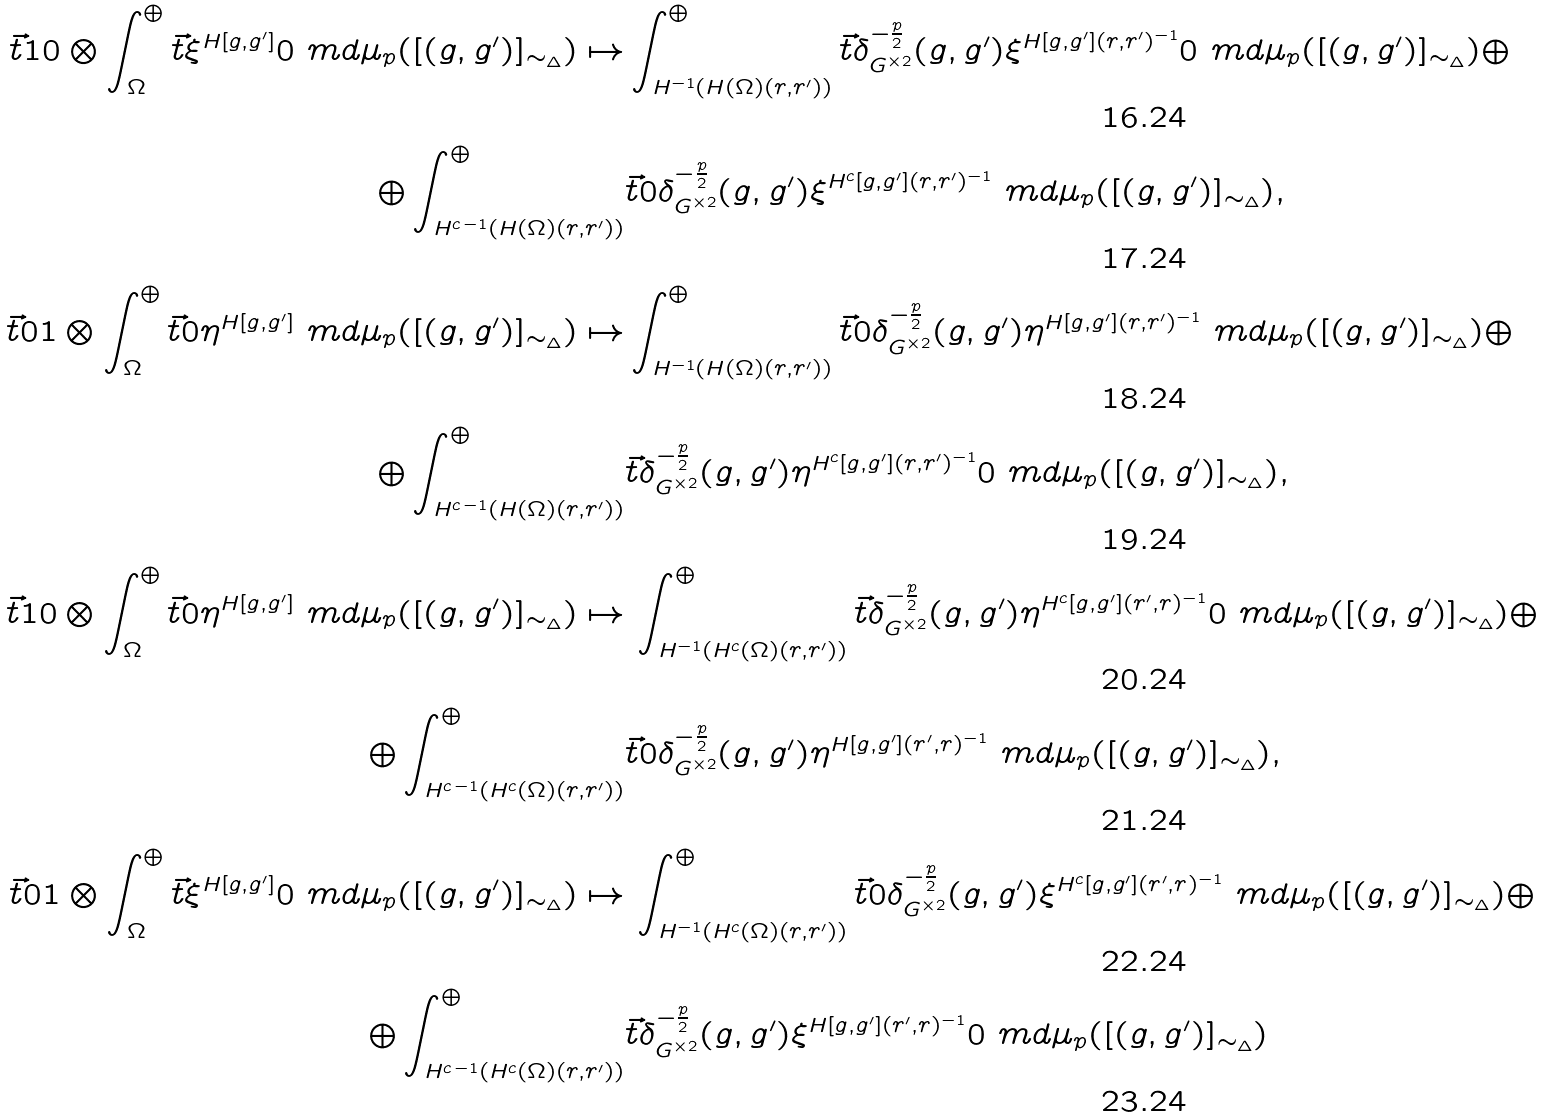<formula> <loc_0><loc_0><loc_500><loc_500>\vec { t } { 1 } { 0 } \otimes \int _ { \Omega } ^ { \oplus } \vec { t } { \xi ^ { H [ g , g ^ { \prime } ] } } { 0 } \ m d \mu _ { p } ( [ ( g , g ^ { \prime } ) ] _ { \sim _ { \Delta } } ) \mapsto & \int _ { H ^ { - 1 } ( H ( \Omega ) ( r , r ^ { \prime } ) ) } ^ { \oplus } \vec { t } { \delta _ { G ^ { \times 2 } } ^ { - \frac { p } { 2 } } ( g , g ^ { \prime } ) \xi ^ { H [ g , g ^ { \prime } ] ( r , r ^ { \prime } ) ^ { - 1 } } } { 0 } \ m d \mu _ { p } ( [ ( g , g ^ { \prime } ) ] _ { \sim _ { \Delta } } ) \oplus \\ \oplus \int _ { H ^ { c \, - 1 } ( H ( \Omega ) ( r , r ^ { \prime } ) ) } ^ { \oplus } & \vec { t } { 0 } { \delta _ { G ^ { \times 2 } } ^ { - \frac { p } { 2 } } ( g , g ^ { \prime } ) \xi ^ { H ^ { c } [ g , g ^ { \prime } ] ( r , r ^ { \prime } ) ^ { - 1 } } } \ m d \mu _ { p } ( [ ( g , g ^ { \prime } ) ] _ { \sim _ { \Delta } } ) , \\ \vec { t } { 0 } { 1 } \otimes \int _ { \Omega } ^ { \oplus } \vec { t } { 0 } { \eta ^ { H [ g , g ^ { \prime } ] } } \ m d \mu _ { p } ( [ ( g , g ^ { \prime } ) ] _ { \sim _ { \Delta } } ) \mapsto & \int _ { H ^ { - 1 } ( H ( \Omega ) ( r , r ^ { \prime } ) ) } ^ { \oplus } \vec { t } { 0 } { \delta _ { G ^ { \times 2 } } ^ { - \frac { p } { 2 } } ( g , g ^ { \prime } ) \eta ^ { H [ g , g ^ { \prime } ] ( r , r ^ { \prime } ) ^ { - 1 } } } \ m d \mu _ { p } ( [ ( g , g ^ { \prime } ) ] _ { \sim _ { \Delta } } ) \oplus \\ \oplus \int _ { H ^ { c \, - 1 } ( H ( \Omega ) ( r , r ^ { \prime } ) ) } ^ { \oplus } & \vec { t } { \delta _ { G ^ { \times 2 } } ^ { - \frac { p } { 2 } } ( g , g ^ { \prime } ) \eta ^ { H ^ { c } [ g , g ^ { \prime } ] ( r , r ^ { \prime } ) ^ { - 1 } } } { 0 } \ m d \mu _ { p } ( [ ( g , g ^ { \prime } ) ] _ { \sim _ { \Delta } } ) , \\ \vec { t } { 1 } { 0 } \otimes \int _ { \Omega } ^ { \oplus } \vec { t } { 0 } { \eta ^ { H [ g , g ^ { \prime } ] } } \ m d \mu _ { p } ( [ ( g , g ^ { \prime } ) ] _ { \sim _ { \Delta } } ) \mapsto & \, \int _ { H ^ { - 1 } ( H ^ { c } ( \Omega ) ( r , r ^ { \prime } ) ) } ^ { \oplus } \vec { t } { \delta _ { G ^ { \times 2 } } ^ { - \frac { p } { 2 } } ( g , g ^ { \prime } ) \eta ^ { H ^ { c } [ g , g ^ { \prime } ] ( r ^ { \prime } , r ) ^ { - 1 } } } { 0 } \ m d \mu _ { p } ( [ ( g , g ^ { \prime } ) ] _ { \sim _ { \Delta } } ) \oplus \\ \oplus \int _ { H ^ { c \, - 1 } ( H ^ { c } ( \Omega ) ( r , r ^ { \prime } ) ) } ^ { \oplus } & \vec { t } { 0 } { \delta _ { G ^ { \times 2 } } ^ { - \frac { p } { 2 } } ( g , g ^ { \prime } ) \eta ^ { H [ g , g ^ { \prime } ] ( r ^ { \prime } , r ) ^ { - 1 } } } \ m d \mu _ { p } ( [ ( g , g ^ { \prime } ) ] _ { \sim _ { \Delta } } ) , \\ \vec { t } { 0 } { 1 } \otimes \int _ { \Omega } ^ { \oplus } \vec { t } { \xi ^ { H [ g , g ^ { \prime } ] } } { 0 } \ m d \mu _ { p } ( [ ( g , g ^ { \prime } ) ] _ { \sim _ { \Delta } } ) \mapsto & \, \int _ { H ^ { - 1 } ( H ^ { c } ( \Omega ) ( r , r ^ { \prime } ) ) } ^ { \oplus } \vec { t } { 0 } { \delta _ { G ^ { \times 2 } } ^ { - \frac { p } { 2 } } ( g , g ^ { \prime } ) \xi ^ { H ^ { c } [ g , g ^ { \prime } ] ( r ^ { \prime } , r ) ^ { - 1 } } } \ m d \mu _ { p } ( [ ( g , g ^ { \prime } ) ] _ { \sim _ { \Delta } } ) \oplus \\ \oplus \int _ { H ^ { c \, - 1 } ( H ^ { c } ( \Omega ) ( r , r ^ { \prime } ) ) } ^ { \oplus } & \vec { t } { \delta _ { G ^ { \times 2 } } ^ { - \frac { p } { 2 } } ( g , g ^ { \prime } ) \xi ^ { H [ g , g ^ { \prime } ] ( r ^ { \prime } , r ) ^ { - 1 } } } { 0 } \ m d \mu _ { p } ( [ ( g , g ^ { \prime } ) ] _ { \sim _ { \Delta } } )</formula> 